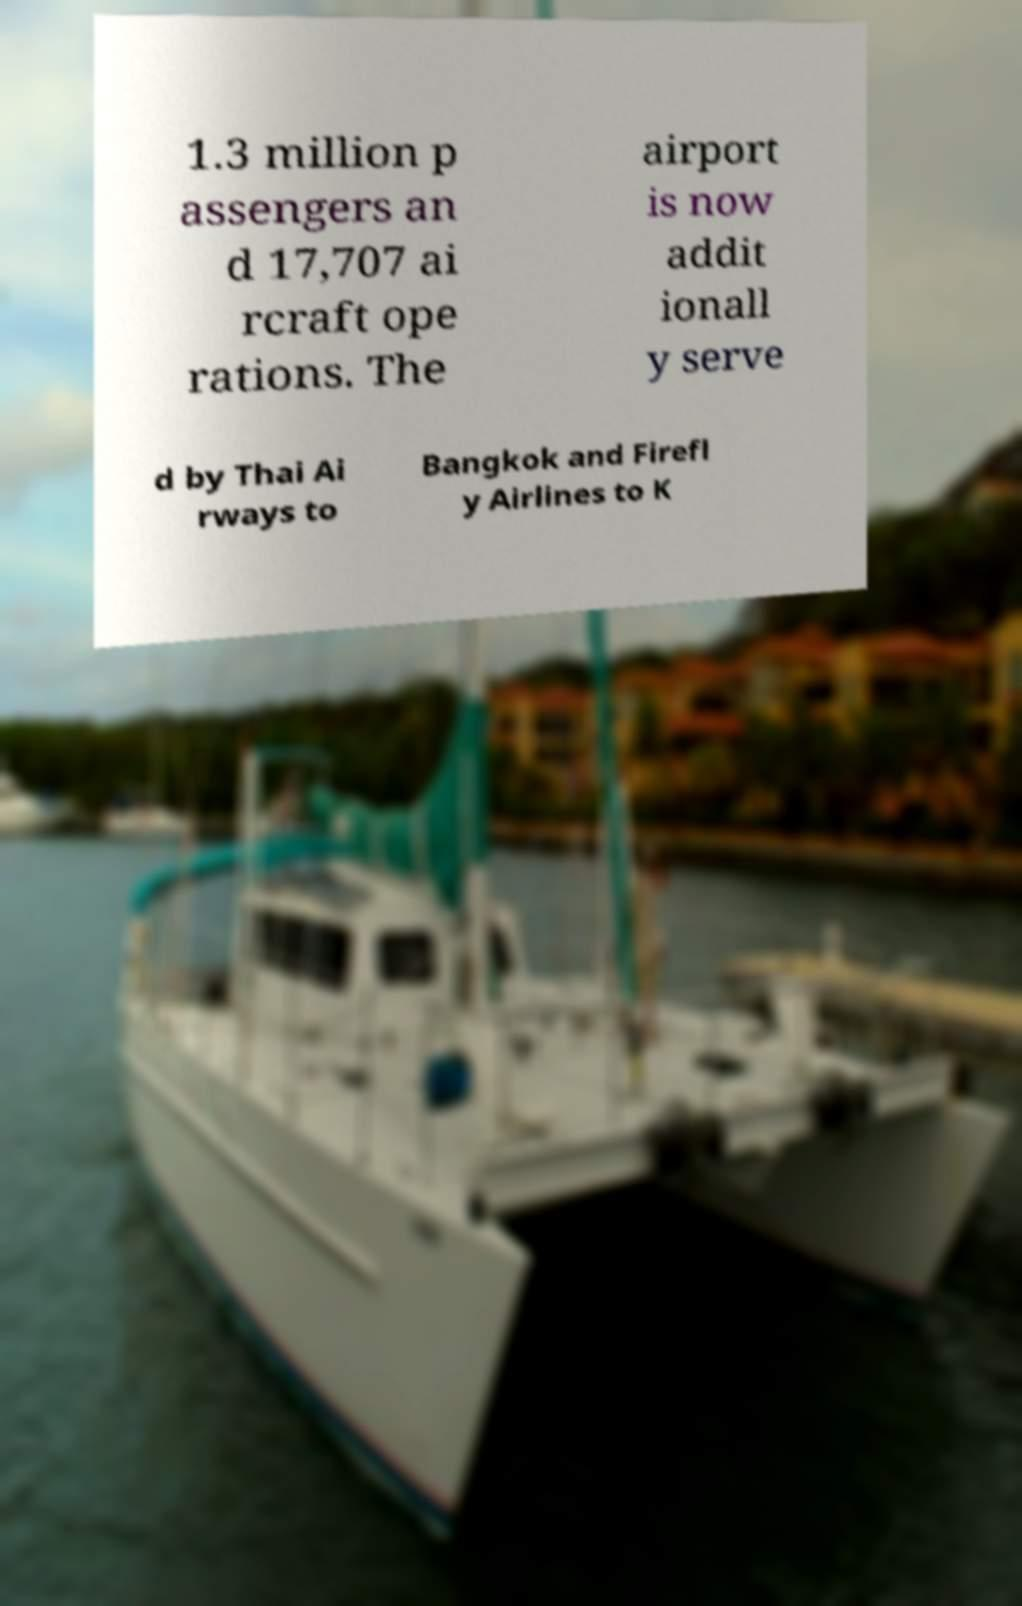What messages or text are displayed in this image? I need them in a readable, typed format. 1.3 million p assengers an d 17,707 ai rcraft ope rations. The airport is now addit ionall y serve d by Thai Ai rways to Bangkok and Firefl y Airlines to K 